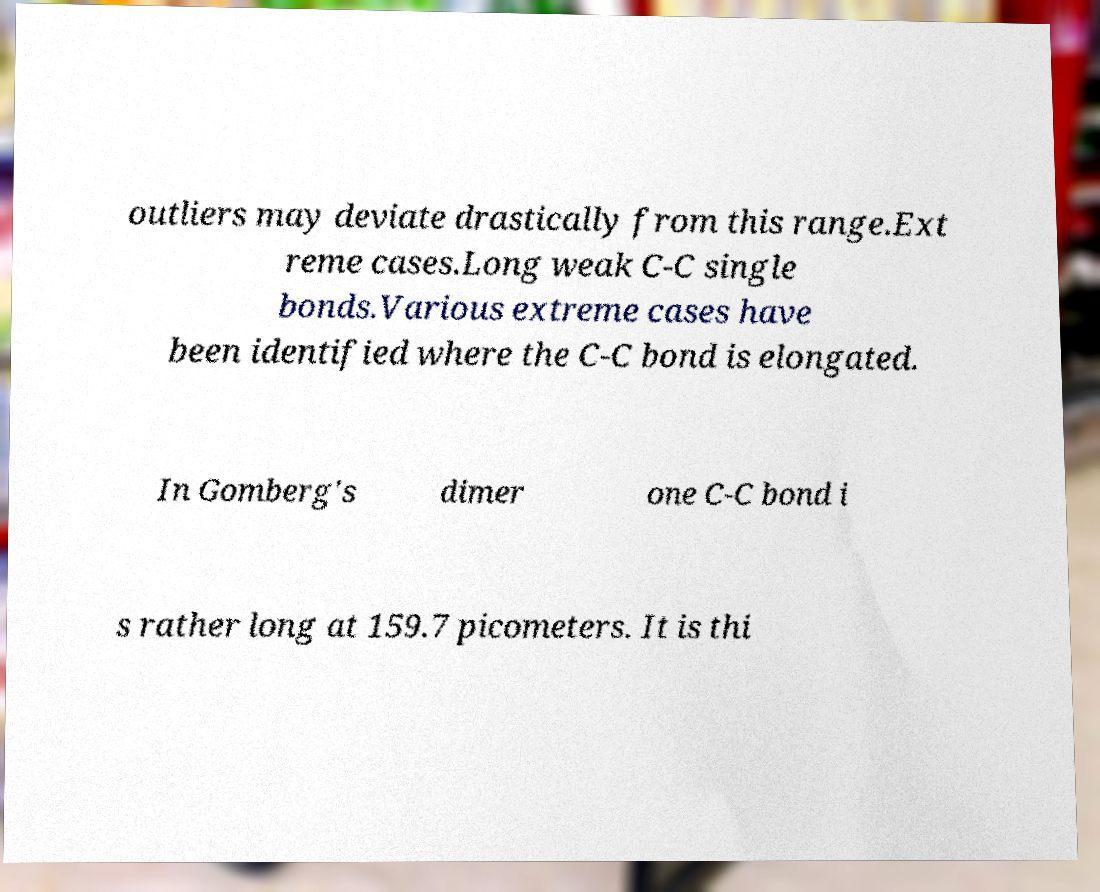Can you read and provide the text displayed in the image?This photo seems to have some interesting text. Can you extract and type it out for me? outliers may deviate drastically from this range.Ext reme cases.Long weak C-C single bonds.Various extreme cases have been identified where the C-C bond is elongated. In Gomberg's dimer one C-C bond i s rather long at 159.7 picometers. It is thi 